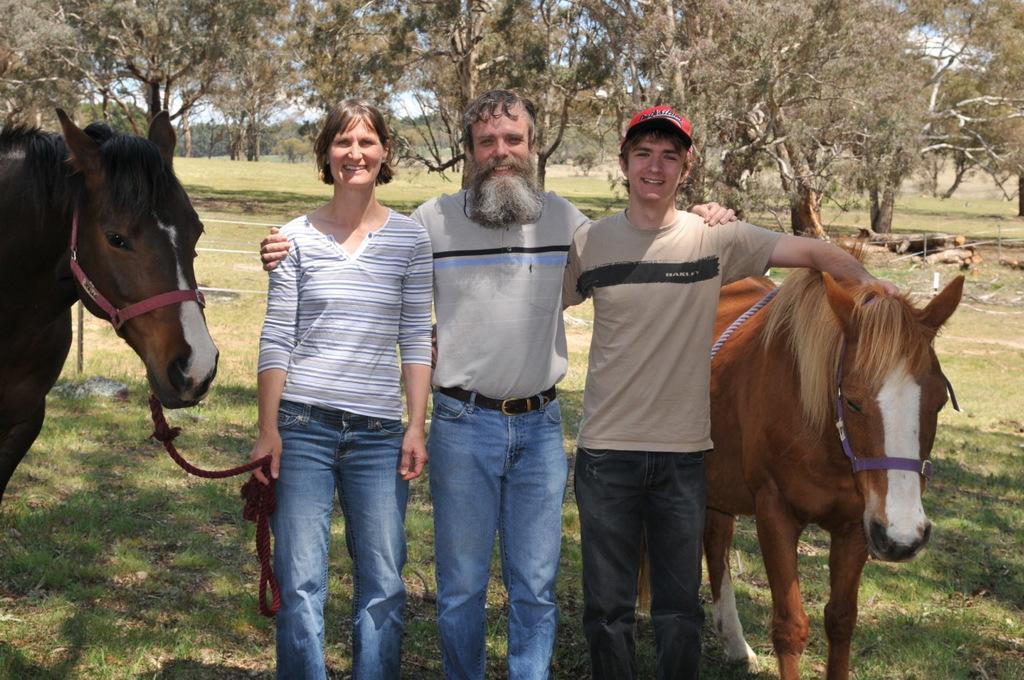Can you describe this image briefly? This image is taken in outdoors. In this image there are three people, at the background there are many trees, there is a grass. In the left side of the image there is a horse and the rope which is tied to horse was held by this woman. In the middle of the image there is a man with beard. In the right side of the image there is a man standing with the horse. 